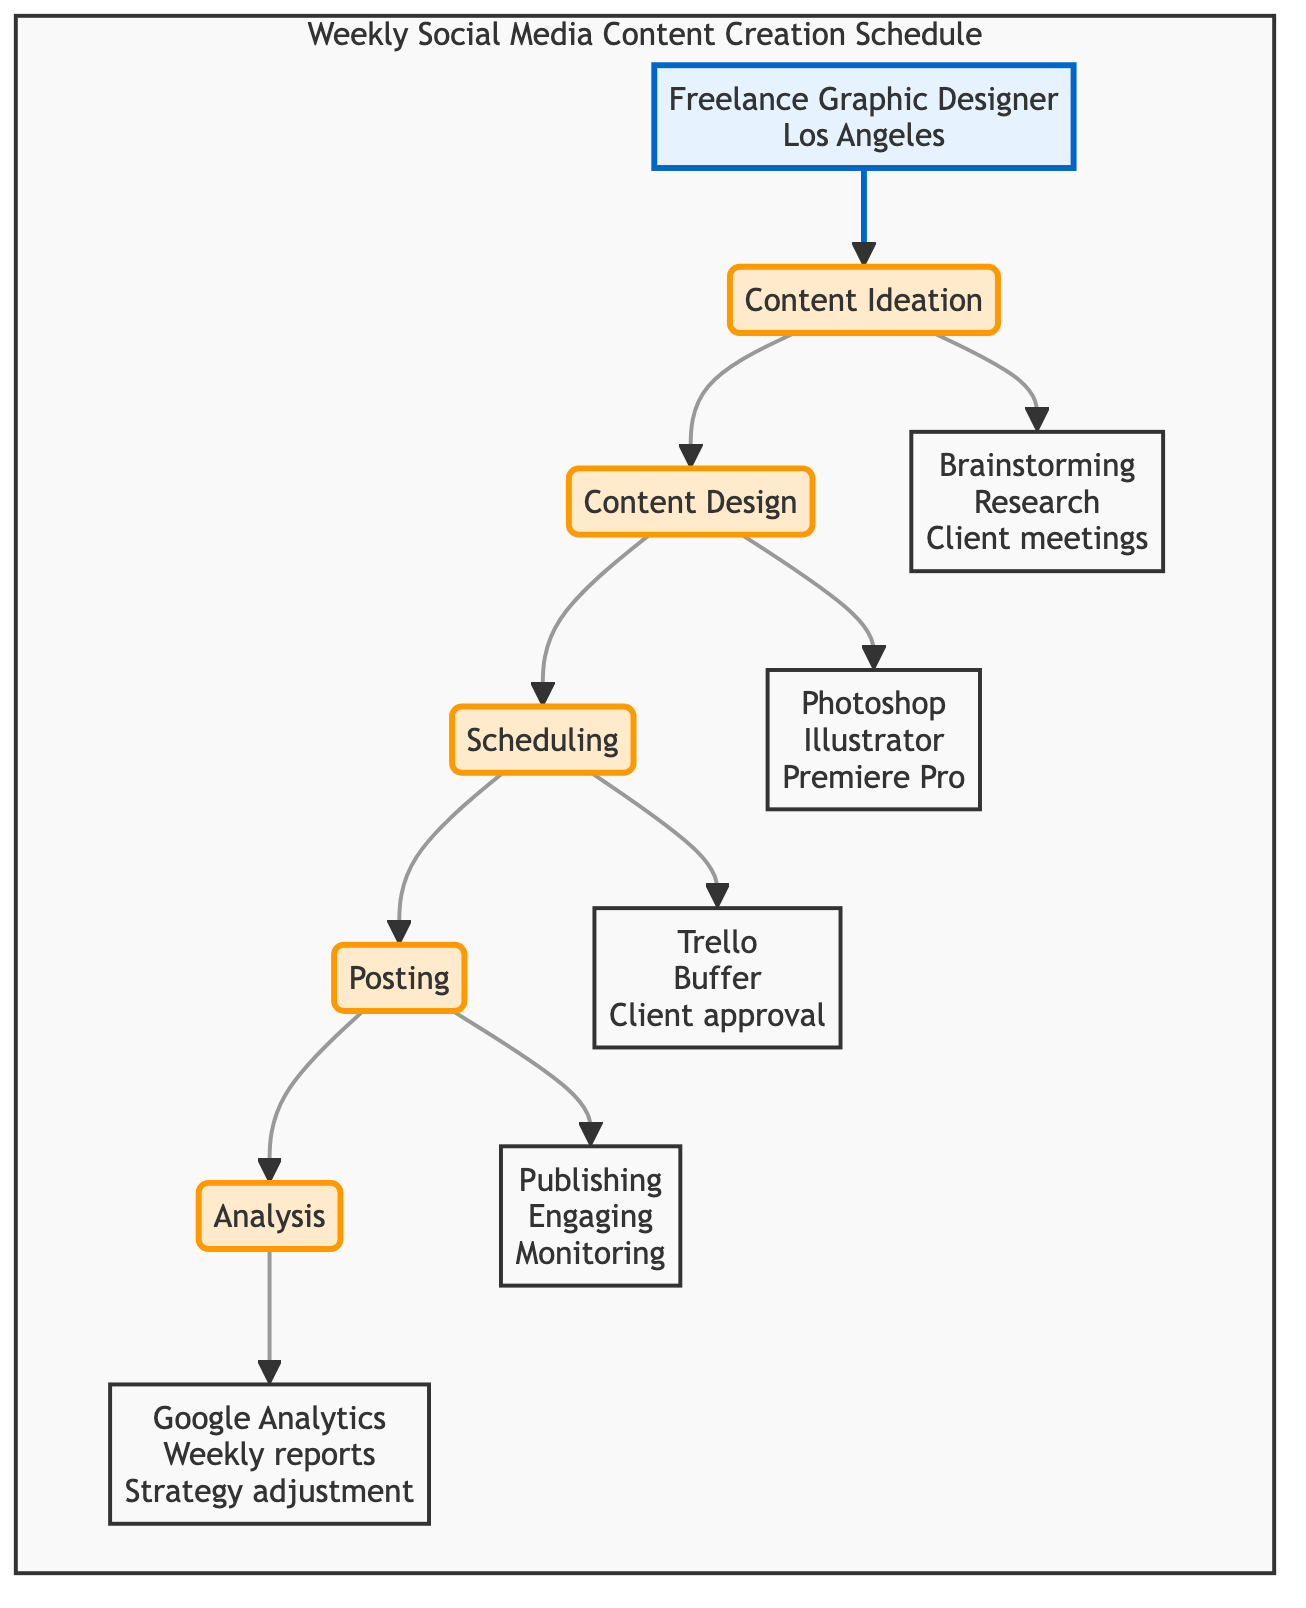What is the first stage in the content creation schedule? The diagram shows that the first stage is "Content Ideation," which is directly connected to the "Freelance Graphic Designer" persona, indicating where the process begins.
Answer: Content Ideation How many main stages are present in the diagram? The diagram outlines five main stages of the content creation process: Content Ideation, Content Design, Scheduling, Posting, and Analysis, which can be counted directly from the flowchart.
Answer: 5 What activities are performed in the Content Design stage? The diagram lists three activities under "Content Design": Creating visual assets in Adobe Photoshop, Designing infographics in Illustrator, and Editing videos in Adobe Premiere Pro, reflecting the responsibilities at that stage.
Answer: Creating visual assets in Adobe Photoshop, Designing infographics in Illustrator, Editing videos in Adobe Premiere Pro Which stage leads directly to Posting? Observing the flow from the diagram, it is clear that "Scheduling" is the stage that leads directly into the "Posting" stage, indicating the sequence of tasks.
Answer: Scheduling What activities are involved in the Analysis stage? The diagram specifies three activities related to "Analysis": Analyzing performance metrics in Google Analytics, Compiling weekly reports, and Adjusting strategy based on insights, showing what is conducted for performance evaluation.
Answer: Analyzing performance metrics in Google Analytics, Compiling weekly reports, Adjusting strategy based on insights What is the sequence of stages from Content Ideation to Analysis? The sequence, as presented in the flowchart, moves from Content Ideation to Content Design, then to Scheduling, followed by Posting, and ends at Analysis, which outlines the order in which tasks are completed.
Answer: Content Ideation, Content Design, Scheduling, Posting, Analysis In which stage do client meetings occur? The activities listed under "Content Ideation" include "Client meetings for content ideas," indicating that this is the stage where client interactions take place.
Answer: Content Ideation What design software is used in the Content Design stage? The diagram specifies that Adobe Photoshop, Illustrator, and Premiere Pro are the design software used in the "Content Design" stage, which can be gleaned from the activities listed.
Answer: Adobe Photoshop, Illustrator, Premiere Pro What type of chart is used to visualize the content creation schedule? The diagram is labeled as a "horizontal flowchart," which defines the structure and style of representation for the content creation process.
Answer: horizontal flowchart 